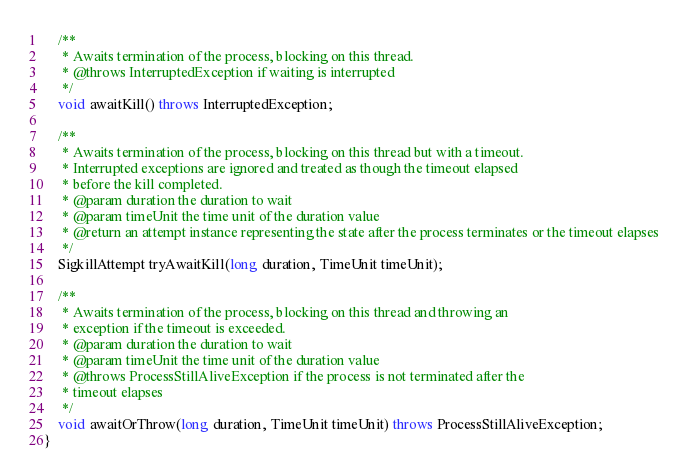<code> <loc_0><loc_0><loc_500><loc_500><_Java_>    /**
     * Awaits termination of the process, blocking on this thread.
     * @throws InterruptedException if waiting is interrupted
     */
    void awaitKill() throws InterruptedException;

    /**
     * Awaits termination of the process, blocking on this thread but with a timeout.
     * Interrupted exceptions are ignored and treated as though the timeout elapsed
     * before the kill completed.
     * @param duration the duration to wait
     * @param timeUnit the time unit of the duration value
     * @return an attempt instance representing the state after the process terminates or the timeout elapses
     */
    SigkillAttempt tryAwaitKill(long duration, TimeUnit timeUnit);

    /**
     * Awaits termination of the process, blocking on this thread and throwing an
     * exception if the timeout is exceeded.
     * @param duration the duration to wait
     * @param timeUnit the time unit of the duration value
     * @throws ProcessStillAliveException if the process is not terminated after the
     * timeout elapses
     */
    void awaitOrThrow(long duration, TimeUnit timeUnit) throws ProcessStillAliveException;
}
</code> 